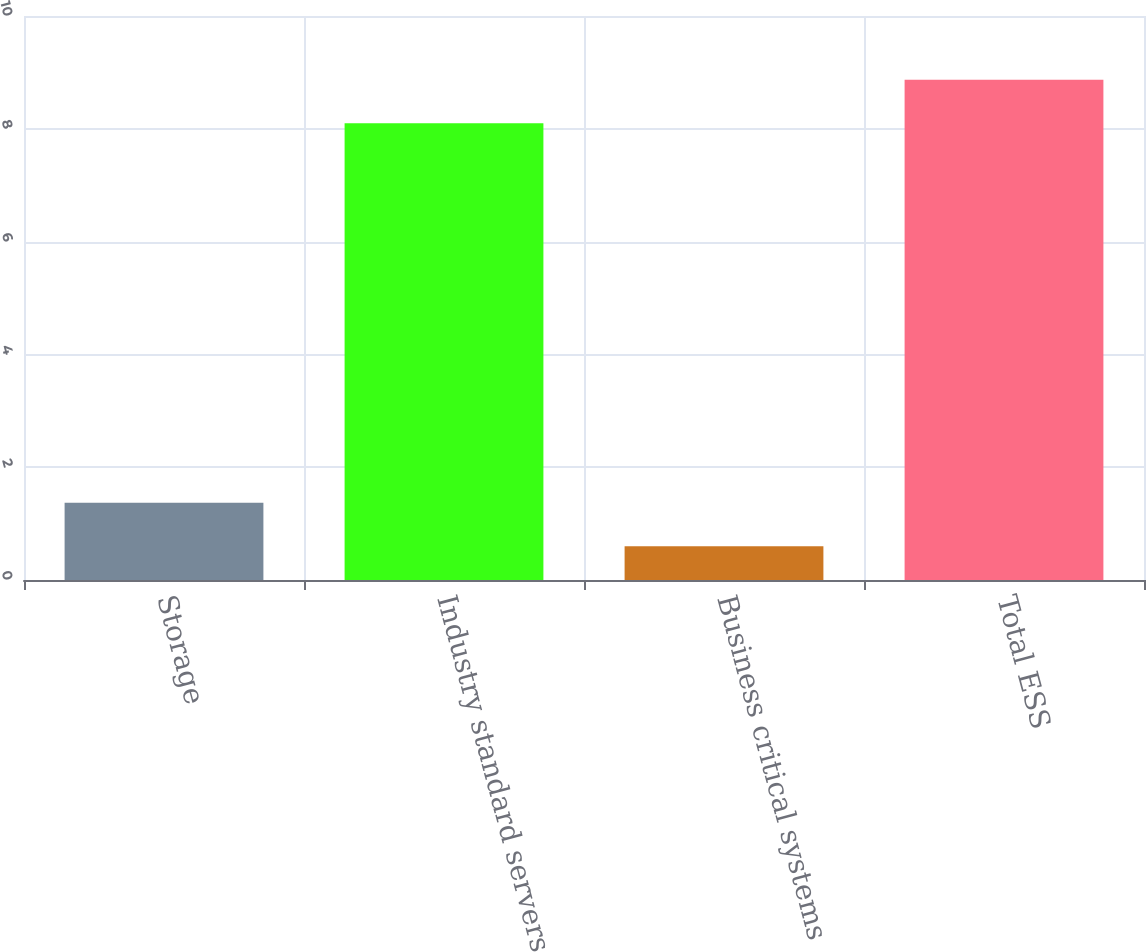Convert chart. <chart><loc_0><loc_0><loc_500><loc_500><bar_chart><fcel>Storage<fcel>Industry standard servers<fcel>Business critical systems<fcel>Total ESS<nl><fcel>1.37<fcel>8.1<fcel>0.6<fcel>8.87<nl></chart> 